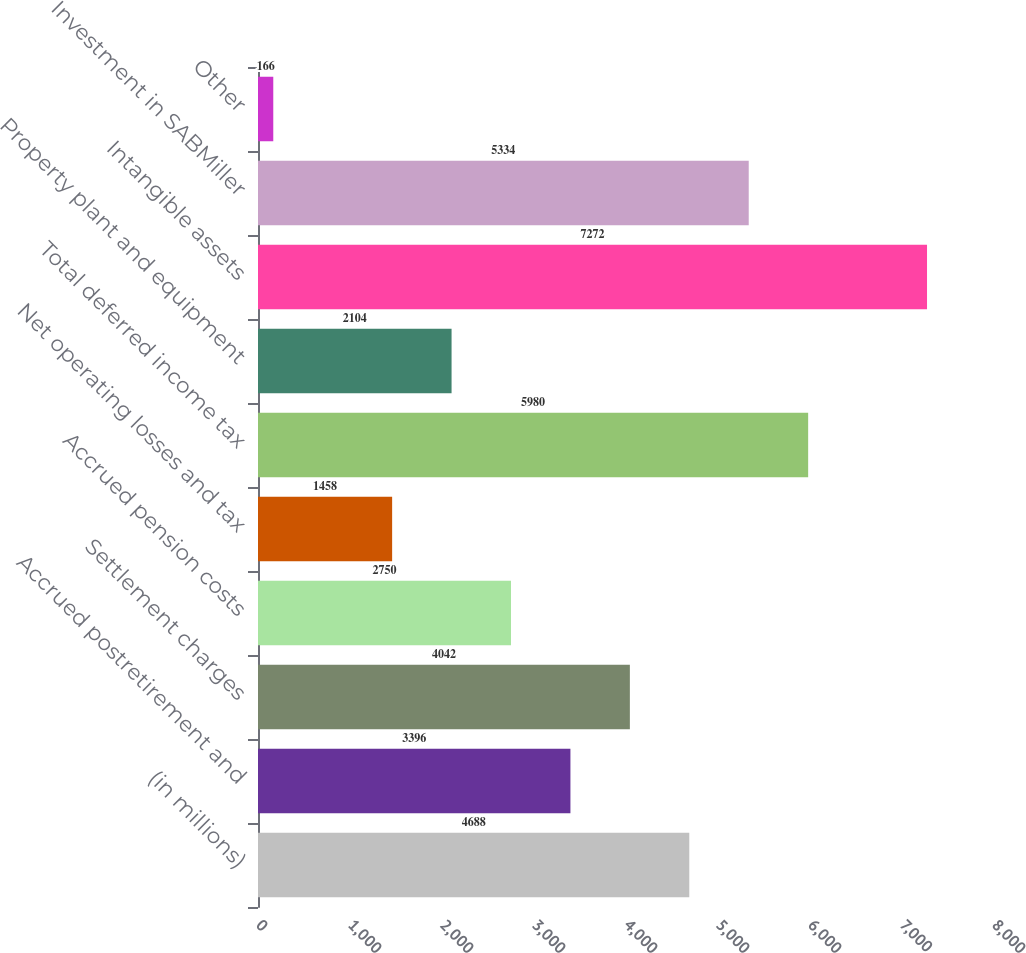Convert chart to OTSL. <chart><loc_0><loc_0><loc_500><loc_500><bar_chart><fcel>(in millions)<fcel>Accrued postretirement and<fcel>Settlement charges<fcel>Accrued pension costs<fcel>Net operating losses and tax<fcel>Total deferred income tax<fcel>Property plant and equipment<fcel>Intangible assets<fcel>Investment in SABMiller<fcel>Other<nl><fcel>4688<fcel>3396<fcel>4042<fcel>2750<fcel>1458<fcel>5980<fcel>2104<fcel>7272<fcel>5334<fcel>166<nl></chart> 